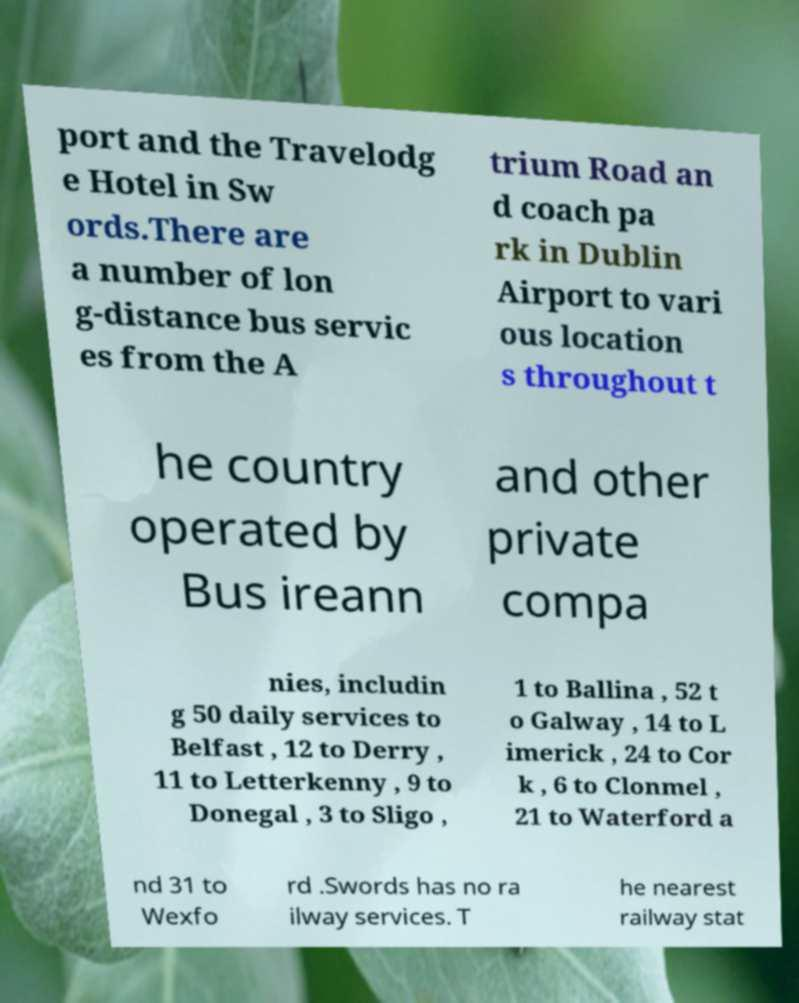I need the written content from this picture converted into text. Can you do that? port and the Travelodg e Hotel in Sw ords.There are a number of lon g-distance bus servic es from the A trium Road an d coach pa rk in Dublin Airport to vari ous location s throughout t he country operated by Bus ireann and other private compa nies, includin g 50 daily services to Belfast , 12 to Derry , 11 to Letterkenny , 9 to Donegal , 3 to Sligo , 1 to Ballina , 52 t o Galway , 14 to L imerick , 24 to Cor k , 6 to Clonmel , 21 to Waterford a nd 31 to Wexfo rd .Swords has no ra ilway services. T he nearest railway stat 